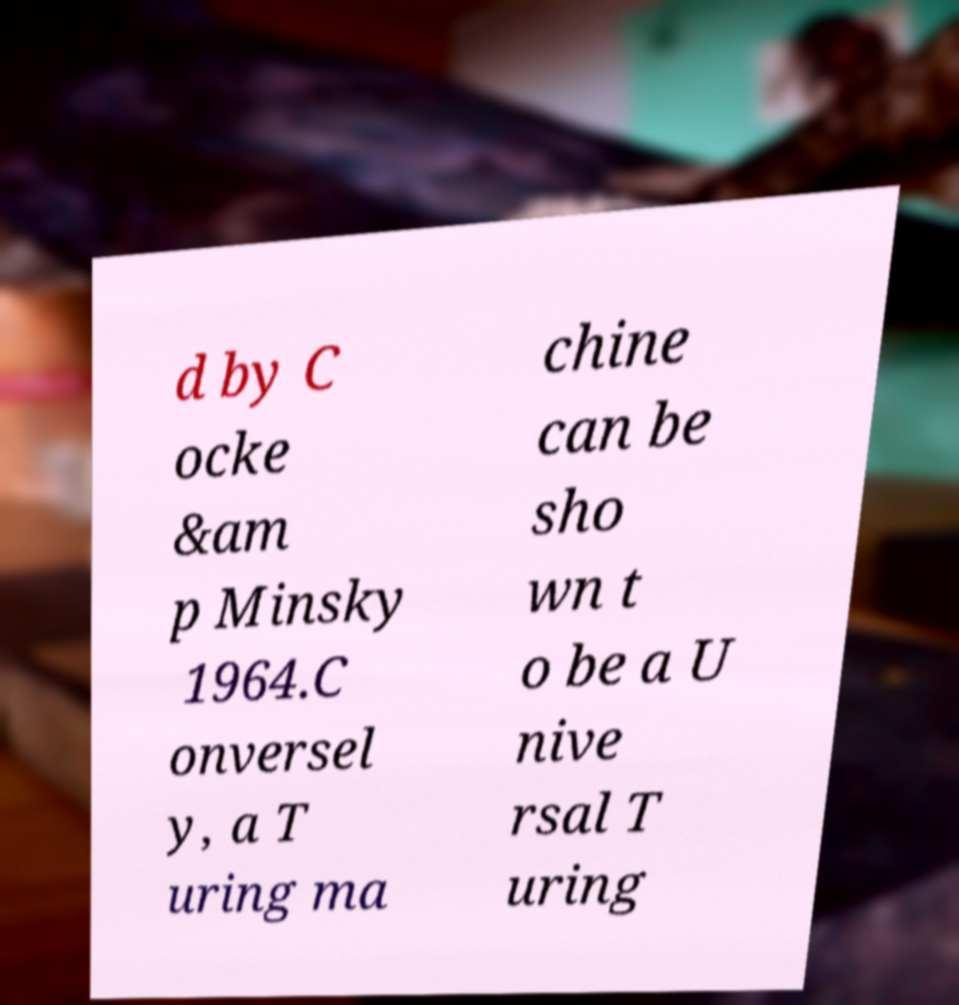Could you extract and type out the text from this image? d by C ocke &am p Minsky 1964.C onversel y, a T uring ma chine can be sho wn t o be a U nive rsal T uring 